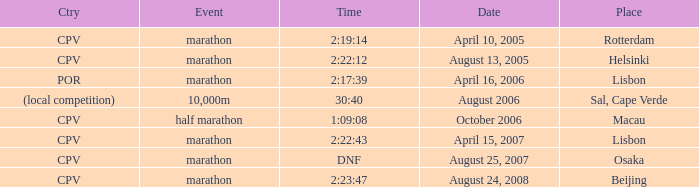What is the Place of the Event on August 25, 2007? Osaka. 